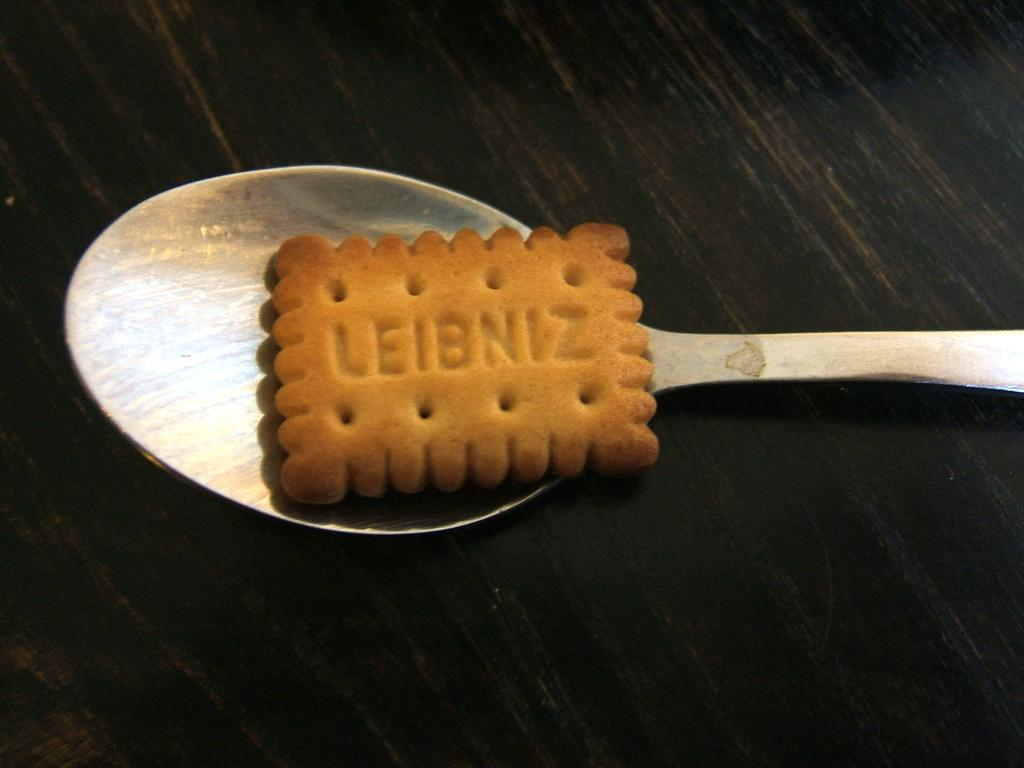What object is present in the image that can be used for eating? There is a spoon in the image that can be used for eating. What is the color of the spoon in the image? The spoon is black in color. What is on the spoon in the image? There is a biscuit on the spoon in the image. What can be seen on the biscuit in the image? The biscuit has text written on it. What is the condition of the sink in the image? There is no sink present in the image. How does the spoon help the person sleep in the image? The spoon does not help the person sleep in the image; it is used for eating. 